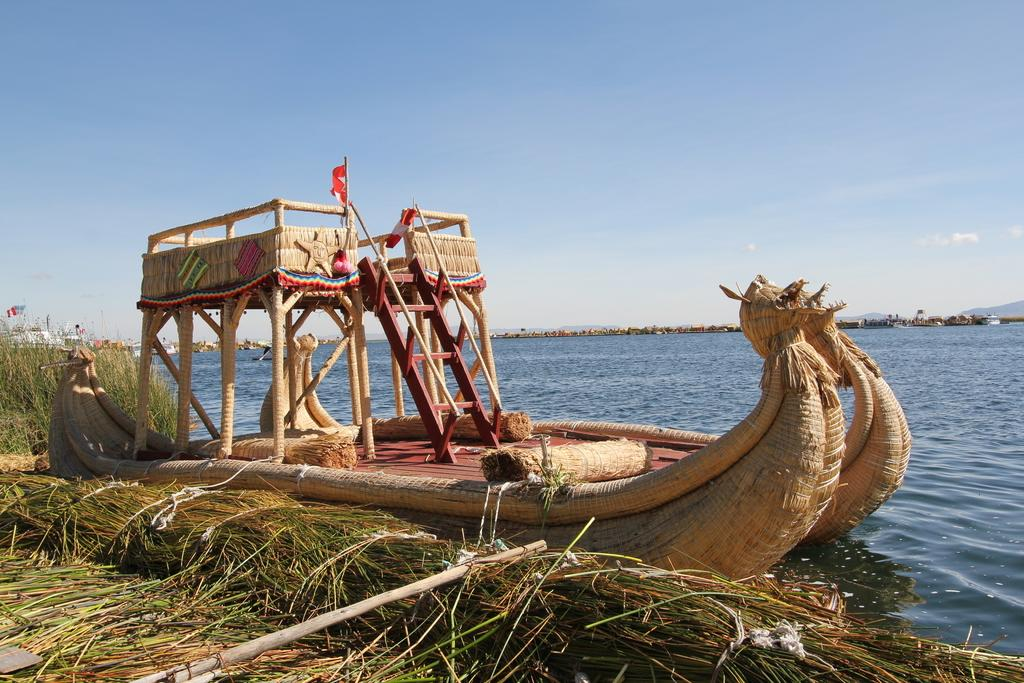What is the main subject of the image? There is a boat in the image. What type of terrain can be seen in the image? There is grass in the image. What is visible in the background of the image? There is water and the sky visible in the background of the image. Can you see the veil of the bride near the boat in the image? There is no veil or bride present in the image; it features a boat, grass, water, and the sky. 